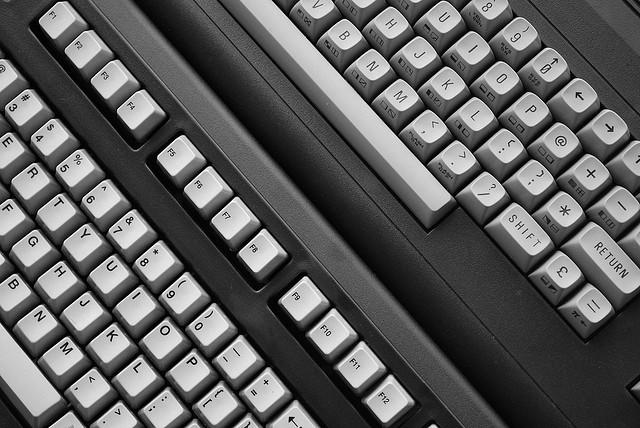How many keyboards are there?
Be succinct. 2. What are these devices used for?
Quick response, please. Typing. What brand is the keyboard?
Concise answer only. Dell. How many Function keys are on the keyboards?
Quick response, please. 12. 